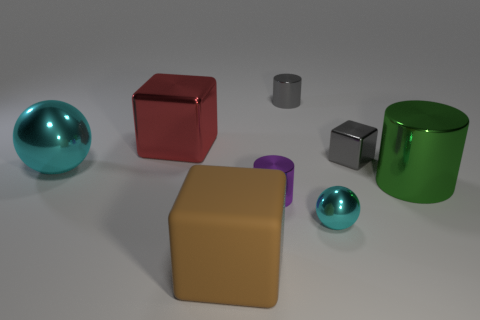Add 2 small gray metallic cylinders. How many objects exist? 10 Subtract all blocks. How many objects are left? 5 Subtract all big red metal cylinders. Subtract all big objects. How many objects are left? 4 Add 6 shiny blocks. How many shiny blocks are left? 8 Add 2 large cubes. How many large cubes exist? 4 Subtract 0 blue cylinders. How many objects are left? 8 